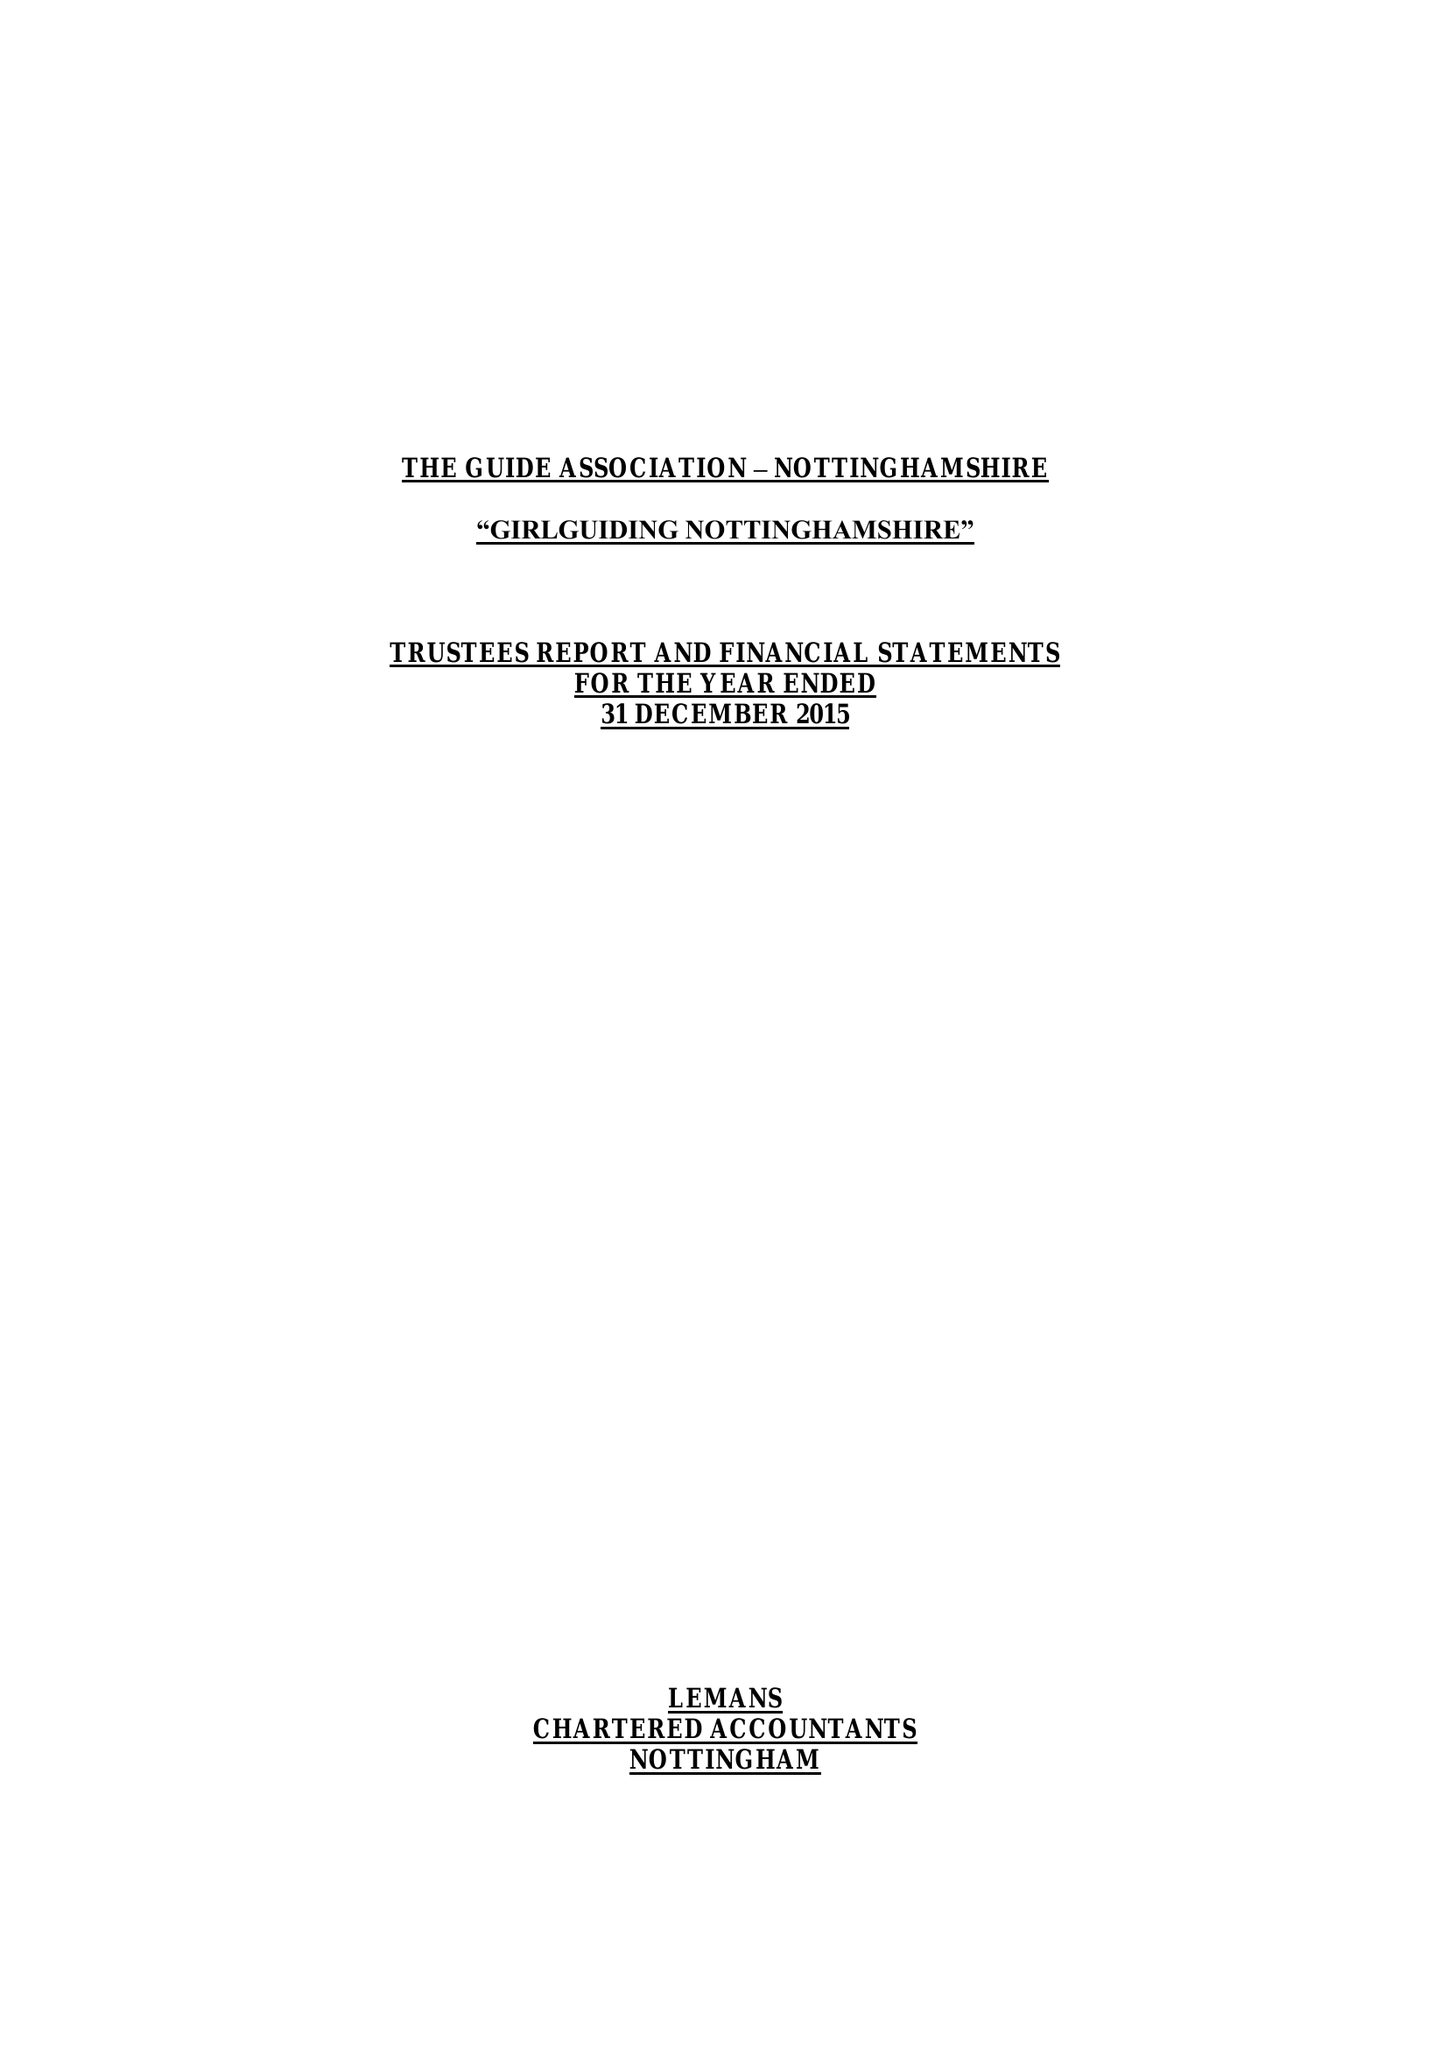What is the value for the spending_annually_in_british_pounds?
Answer the question using a single word or phrase. 233831.00 